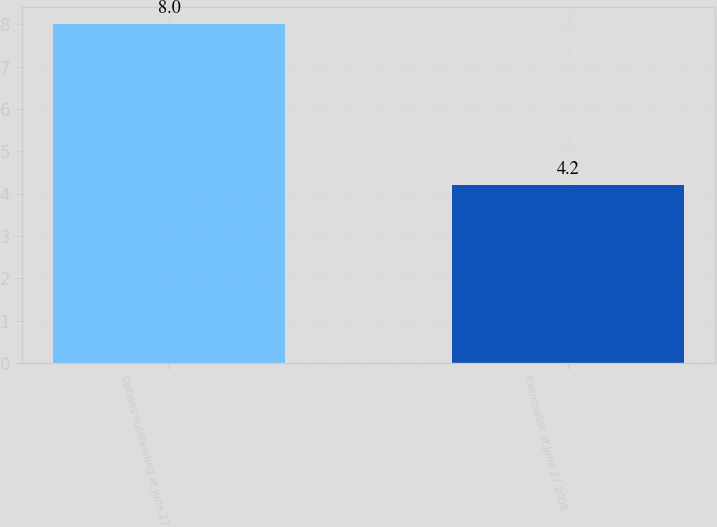Convert chart. <chart><loc_0><loc_0><loc_500><loc_500><bar_chart><fcel>Options outstanding at June 27<fcel>Exercisable at June 27 2008<nl><fcel>8<fcel>4.2<nl></chart> 